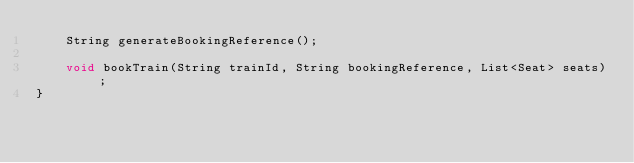<code> <loc_0><loc_0><loc_500><loc_500><_Java_>    String generateBookingReference();

    void bookTrain(String trainId, String bookingReference, List<Seat> seats);
}
</code> 